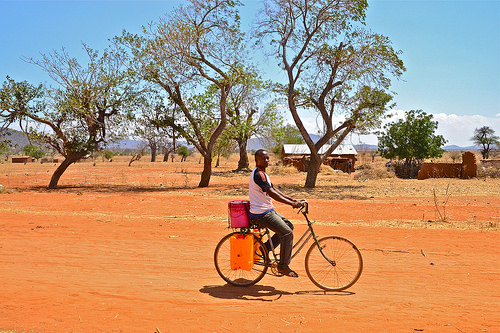<image>
Is there a person on the bike? Yes. Looking at the image, I can see the person is positioned on top of the bike, with the bike providing support. Is the man on the bicycle? Yes. Looking at the image, I can see the man is positioned on top of the bicycle, with the bicycle providing support. Is there a bicycling man in the savannah? Yes. The bicycling man is contained within or inside the savannah, showing a containment relationship. Is there a old bicycle next to the young man? No. The old bicycle is not positioned next to the young man. They are located in different areas of the scene. 